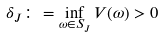Convert formula to latex. <formula><loc_0><loc_0><loc_500><loc_500>\delta _ { J } \colon = \inf _ { \omega \in S _ { J } } V ( \omega ) > 0</formula> 